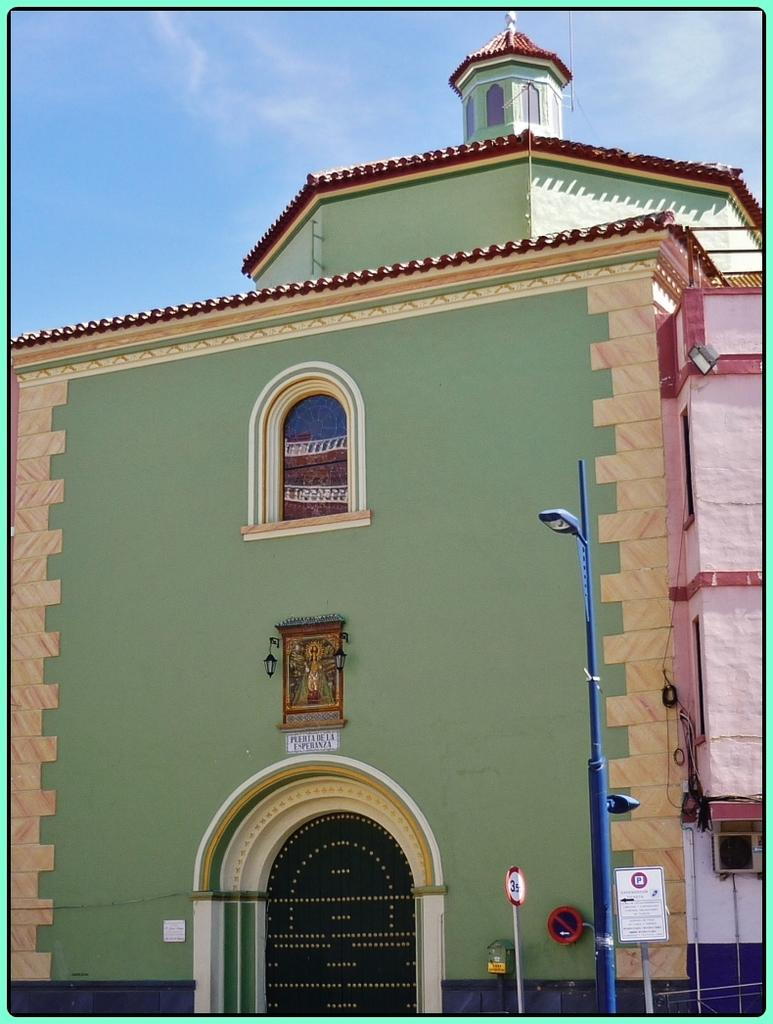What type of structure is present in the image? There is a building in the image. What type of lighting is present in the image? There is a street light in the image. What type of signage is present in the image? There is a name board and sign boards in the image. What else can be seen in the image? There are objects visible in the image. What is visible in the background of the image? The sky is visible in the background of the image. How many chairs are visible in the image? There are no chairs present in the image. How many passengers are visible in the image? There are no passengers present in the image. 